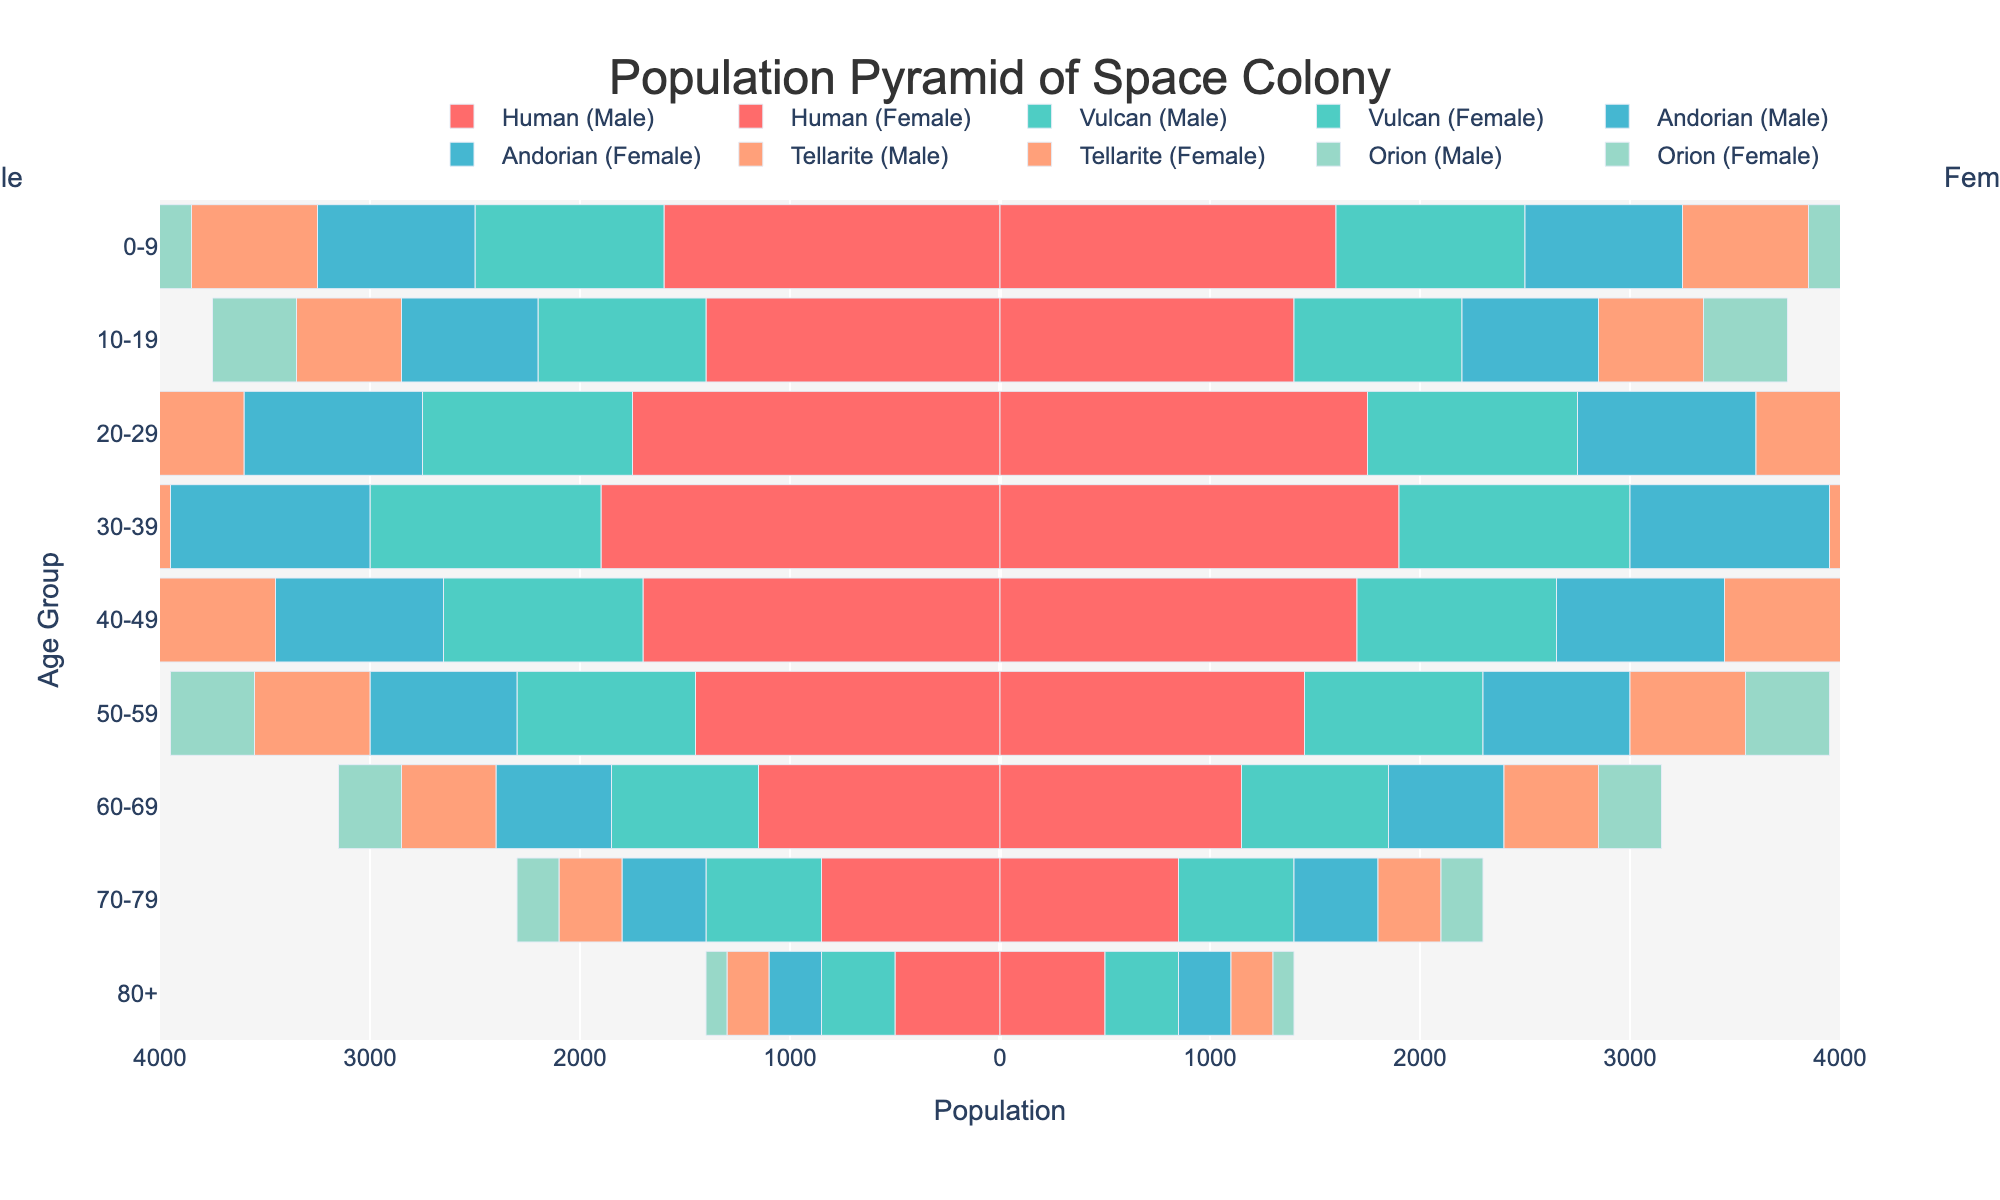What is the title of the figure? The title of a figure is usually displayed at the top. In this case, it is centrally aligned at the top of the chart.
Answer: Population Pyramid of Space Colony How many age groups are there in the population pyramid? By counting the distinct labels on the y-axis of the figure, we can determine the number of age groups.
Answer: 9 Which race has the largest male population in the 30-39 age group? We can determine this by comparing the lengths of the bars in the 30-39 age group for each race on the left side (negative values) of the graph.
Answer: Human How does the female population of Vulcans in the 20-29 age group compare with the female population of Andorians in the same age group? Count the positive lengths of the bars for Vulcans and Andorians in the 20-29 age group. Vulcan female bar is longer.
Answer: Vulcan female population is larger What is the total population for the 40-49 age group across all races? Add up the values for all races (both male and female, effectively taking the absolute value due to split) in the 40-49 age group. Calculation: (3400 + 1900 + 1600 + 1300 + 1000) = 9200.
Answer: 9200 In which age group does the Tellarite population have the lowest number? By examining the lengths of the bars for all age groups, we can identify the age group with the smallest values for Tellarites.
Answer: 80+ Which age group has the highest combined population of all races? To determine this, sum the populations of all races for each age group and compare. The highest sum appears in the 30-39 age group.
Answer: 30-39 How does the combined population of 0-19-year-olds compare to the population of 50-69-year-olds? Sum the values for the 0-9 and 10-19 age groups compared to the combined values for the 50-59 and 60-69 age groups. Calculation: (3200+2800+1800+1600+1500+1300+1200+1000+900+800) = 16200 vs. (2900+1700+1400+1100+800+2300+1400+1100+900+600) = 13500
Answer: 0-19-year-olds have a larger population What visual characteristic distinguishes male from female populations in the plot? Male populations are represented by bars extending to the left (negative axis) and female populations to the right (positive axis) of the central y-axis.
Answer: Male bars are on the left, female bars on the right 